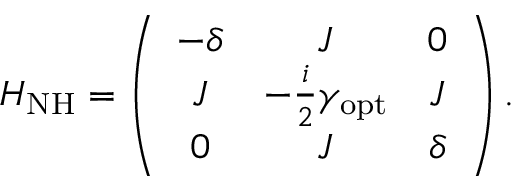Convert formula to latex. <formula><loc_0><loc_0><loc_500><loc_500>H _ { N H } = \left ( \begin{array} { c c c } { - \delta } & { J } & { 0 } \\ { J } & { - \frac { i } { 2 } \gamma _ { o p t } } & { J } \\ { 0 } & { J } & { \delta } \end{array} \right ) .</formula> 